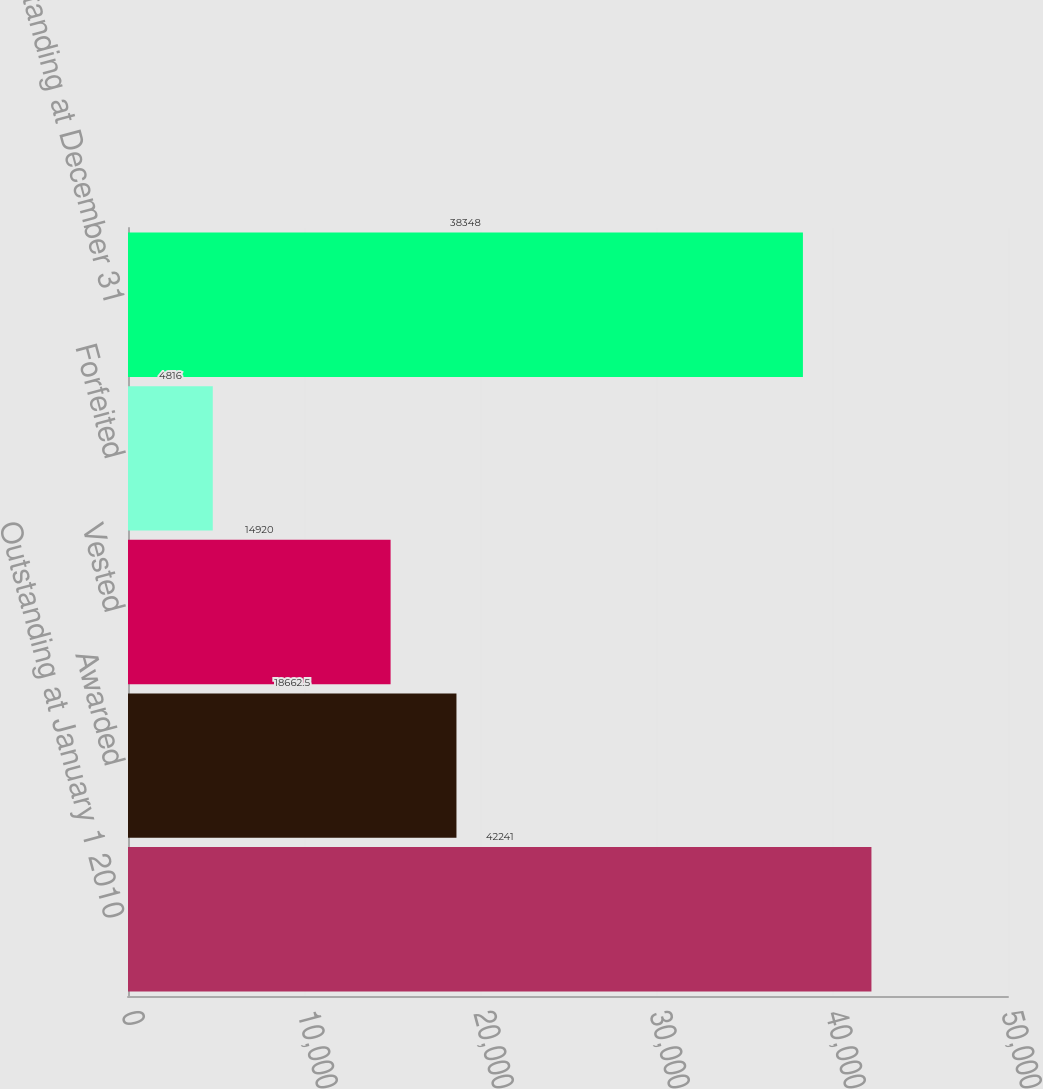Convert chart. <chart><loc_0><loc_0><loc_500><loc_500><bar_chart><fcel>Outstanding at January 1 2010<fcel>Awarded<fcel>Vested<fcel>Forfeited<fcel>Outstanding at December 31<nl><fcel>42241<fcel>18662.5<fcel>14920<fcel>4816<fcel>38348<nl></chart> 